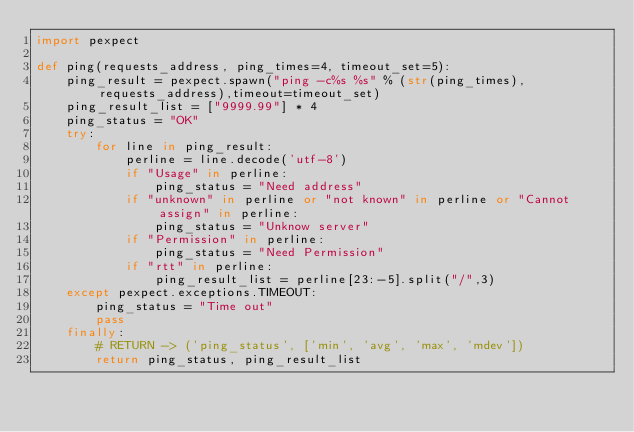Convert code to text. <code><loc_0><loc_0><loc_500><loc_500><_Python_>import pexpect

def ping(requests_address, ping_times=4, timeout_set=5):
    ping_result = pexpect.spawn("ping -c%s %s" % (str(ping_times), requests_address),timeout=timeout_set)
    ping_result_list = ["9999.99"] * 4
    ping_status = "OK"
    try:
        for line in ping_result:
            perline = line.decode('utf-8')
            if "Usage" in perline:
                ping_status = "Need address"
            if "unknown" in perline or "not known" in perline or "Cannot assign" in perline:
                ping_status = "Unknow server"
            if "Permission" in perline:
                ping_status = "Need Permission"
            if "rtt" in perline:
                ping_result_list = perline[23:-5].split("/",3)
    except pexpect.exceptions.TIMEOUT:
        ping_status = "Time out"
        pass
    finally:
        # RETURN -> ('ping_status', ['min', 'avg', 'max', 'mdev'])
        return ping_status, ping_result_list</code> 